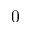<formula> <loc_0><loc_0><loc_500><loc_500>0</formula> 